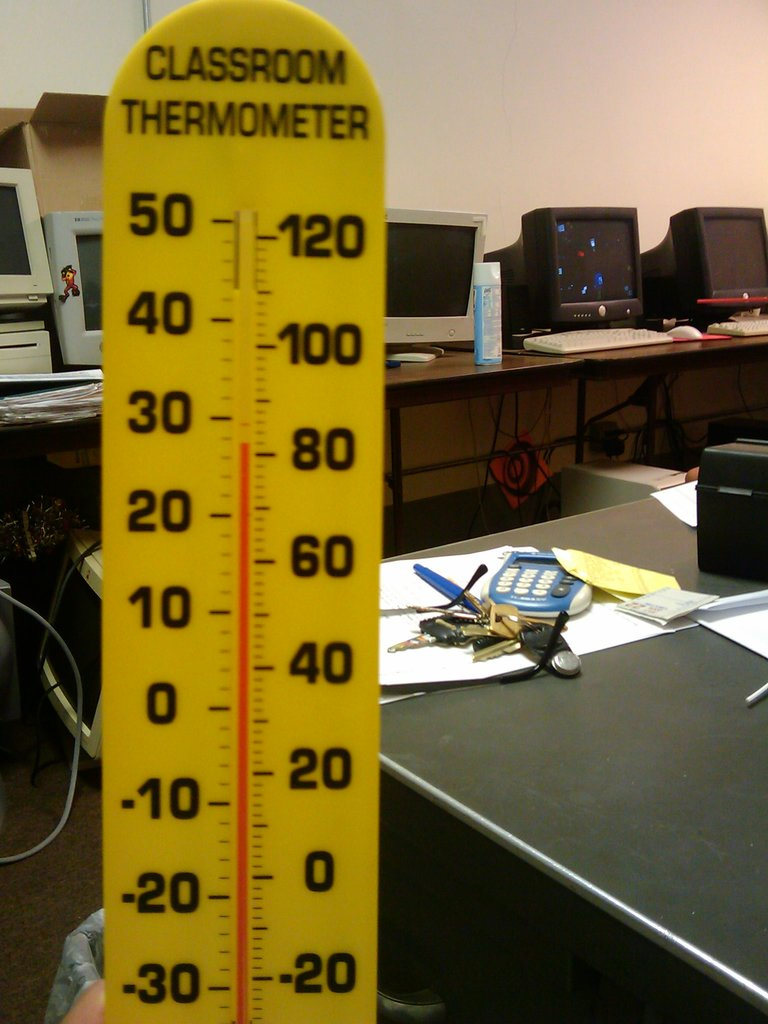How does the environment in this image reflect on its use? The environment shows a practical and somewhat hectic space, likely reflecting multiple uses. The computers suggest digital work or research is done here, while the presence of teaching aids like the thermometer implies that instruction takes place as well. It’s a multifunctional area that blends administrative work with education. What could the temperature on the thermometer indicate about the conditions in the classroom? Although the image doesn't show the current temperature clearly, the range on the thermometer allows for monitoring both very cold and very hot temperatures. This could be useful in assessing the classroom's comfort level or for educational demonstrations involving temperature fluctuations. 